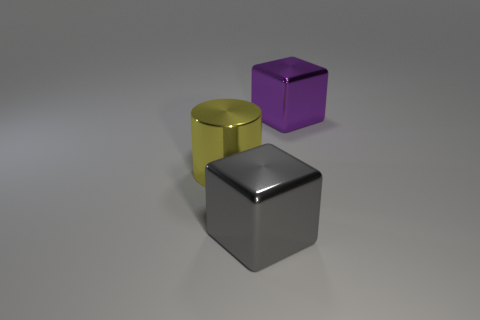Add 3 big yellow objects. How many objects exist? 6 Subtract all cylinders. How many objects are left? 2 Add 3 cylinders. How many cylinders are left? 4 Add 3 purple blocks. How many purple blocks exist? 4 Subtract 0 red cylinders. How many objects are left? 3 Subtract all large gray cylinders. Subtract all large purple things. How many objects are left? 2 